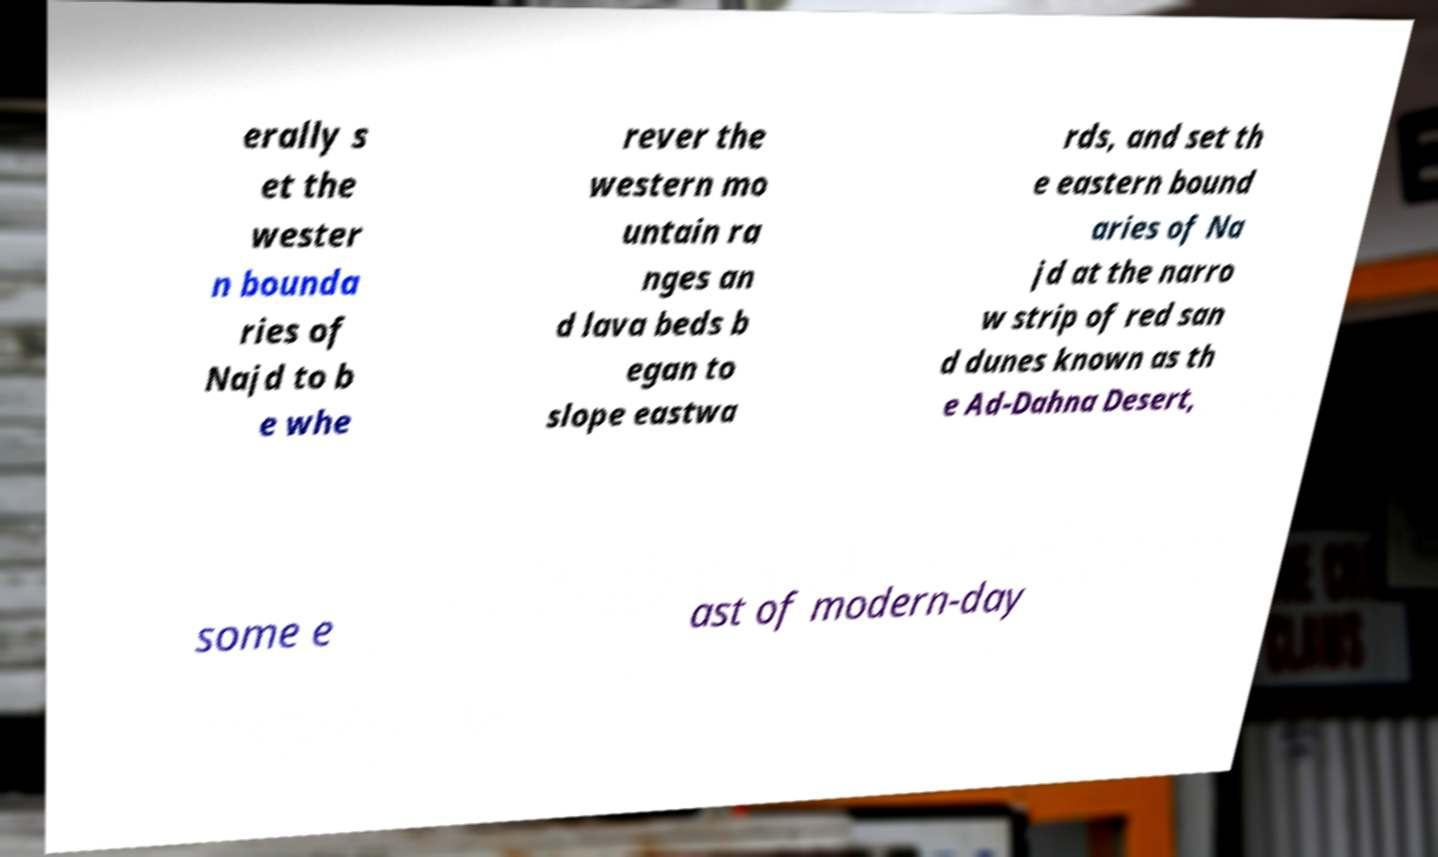Could you extract and type out the text from this image? erally s et the wester n bounda ries of Najd to b e whe rever the western mo untain ra nges an d lava beds b egan to slope eastwa rds, and set th e eastern bound aries of Na jd at the narro w strip of red san d dunes known as th e Ad-Dahna Desert, some e ast of modern-day 